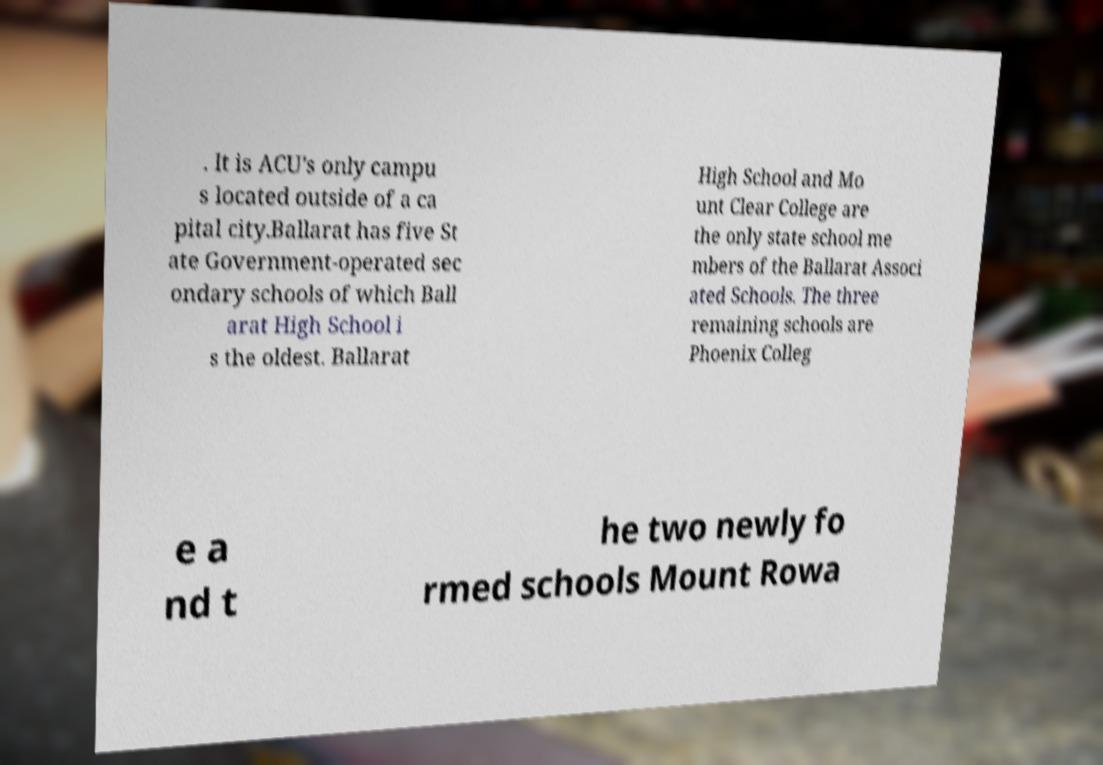Please read and relay the text visible in this image. What does it say? . It is ACU's only campu s located outside of a ca pital city.Ballarat has five St ate Government-operated sec ondary schools of which Ball arat High School i s the oldest. Ballarat High School and Mo unt Clear College are the only state school me mbers of the Ballarat Associ ated Schools. The three remaining schools are Phoenix Colleg e a nd t he two newly fo rmed schools Mount Rowa 